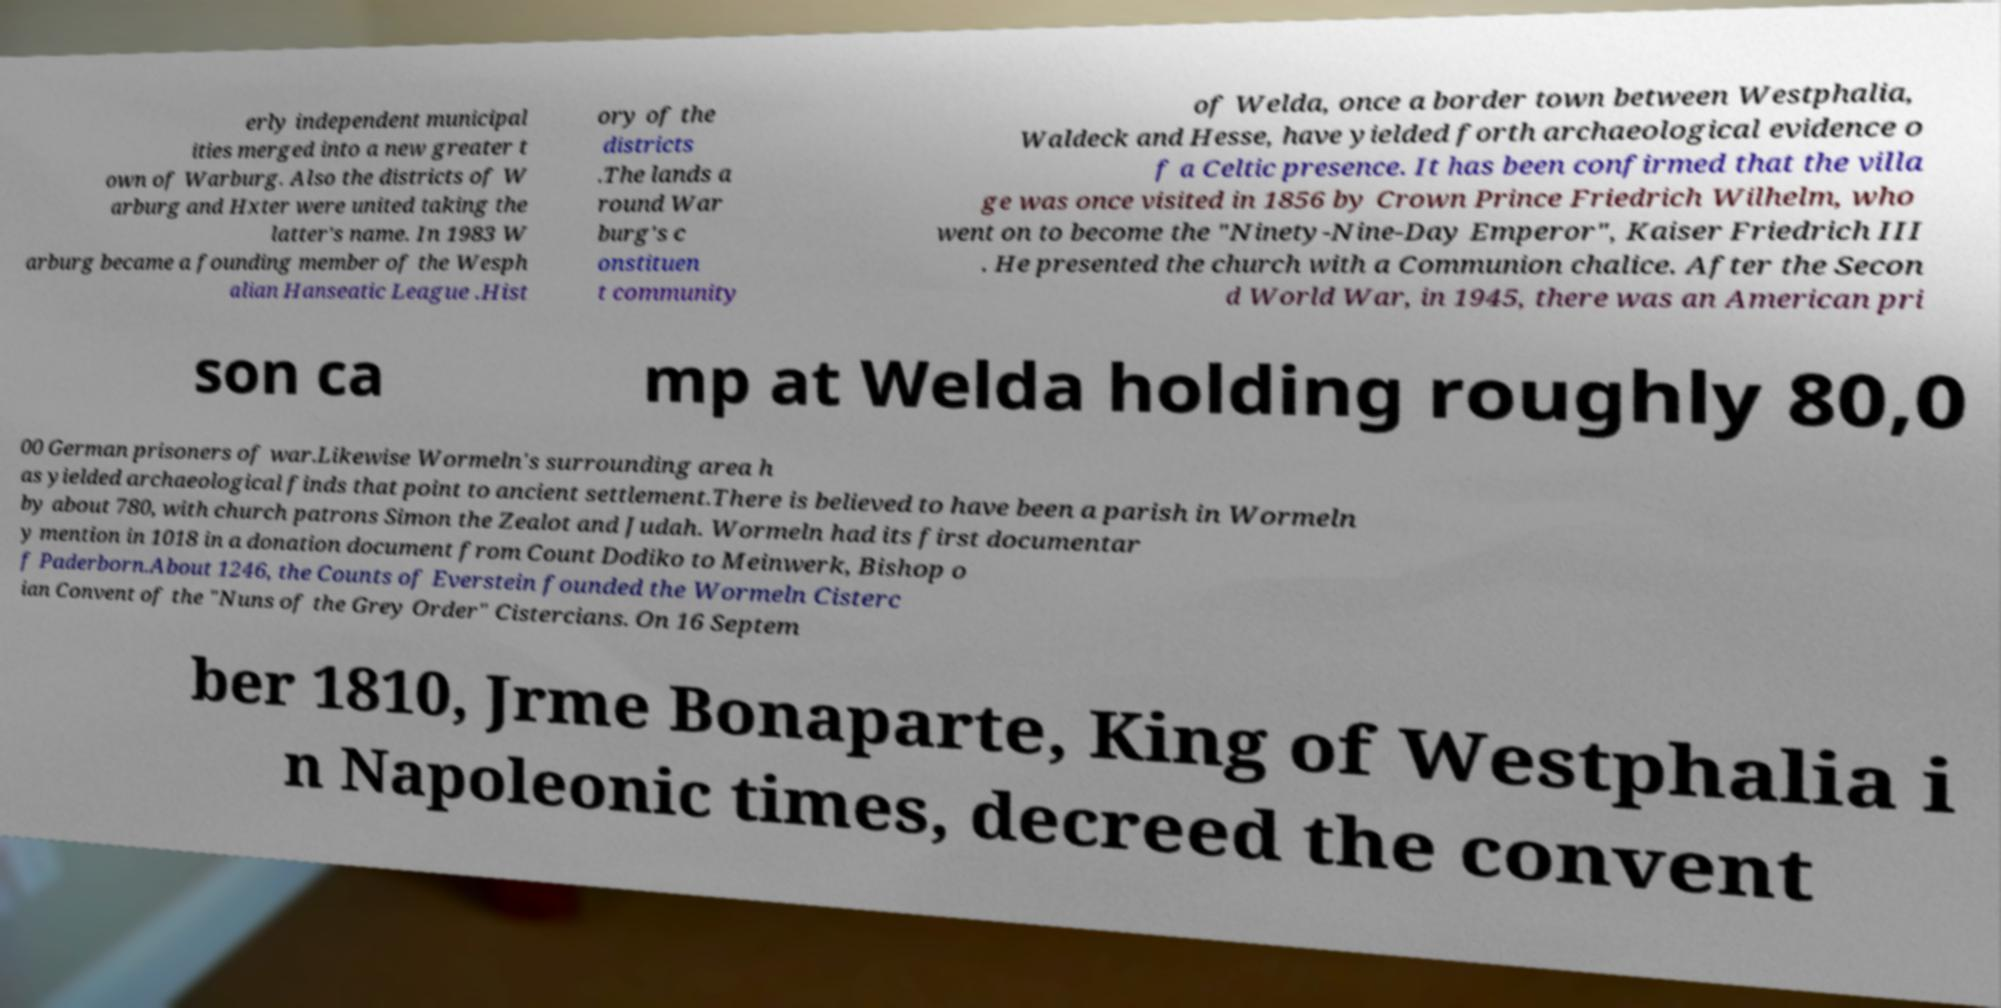Could you assist in decoding the text presented in this image and type it out clearly? erly independent municipal ities merged into a new greater t own of Warburg. Also the districts of W arburg and Hxter were united taking the latter's name. In 1983 W arburg became a founding member of the Wesph alian Hanseatic League .Hist ory of the districts .The lands a round War burg's c onstituen t community of Welda, once a border town between Westphalia, Waldeck and Hesse, have yielded forth archaeological evidence o f a Celtic presence. It has been confirmed that the villa ge was once visited in 1856 by Crown Prince Friedrich Wilhelm, who went on to become the "Ninety-Nine-Day Emperor", Kaiser Friedrich III . He presented the church with a Communion chalice. After the Secon d World War, in 1945, there was an American pri son ca mp at Welda holding roughly 80,0 00 German prisoners of war.Likewise Wormeln's surrounding area h as yielded archaeological finds that point to ancient settlement.There is believed to have been a parish in Wormeln by about 780, with church patrons Simon the Zealot and Judah. Wormeln had its first documentar y mention in 1018 in a donation document from Count Dodiko to Meinwerk, Bishop o f Paderborn.About 1246, the Counts of Everstein founded the Wormeln Cisterc ian Convent of the "Nuns of the Grey Order" Cistercians. On 16 Septem ber 1810, Jrme Bonaparte, King of Westphalia i n Napoleonic times, decreed the convent 